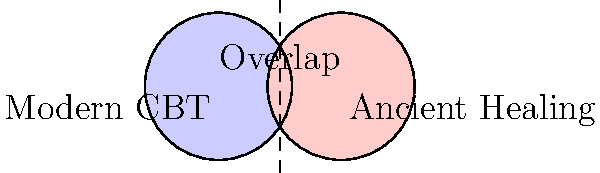In the Venn diagram above, which area represents techniques that are unique to modern Cognitive Behavioral Therapy (CBT) and not found in ancient healing practices? To answer this question, let's analyze the Venn diagram step by step:

1. The diagram consists of two overlapping circles.
2. The left circle (blue) represents "Modern CBT" techniques.
3. The right circle (red) represents "Ancient Healing" practices.
4. The overlapping area in the middle represents techniques that are common to both modern CBT and ancient healing practices.

5. To find the area that represents techniques unique to modern CBT, we need to identify the portion of the "Modern CBT" circle that does not overlap with the "Ancient Healing" circle.

6. This unique area is the left part of the blue circle, which does not intersect with the red circle.

7. In set theory notation, this area can be expressed as:
   $$ \text{Modern CBT} \setminus \text{Ancient Healing} $$
   which reads as "Modern CBT minus Ancient Healing" or "the set of elements in Modern CBT that are not in Ancient Healing."

Therefore, the area representing techniques unique to modern CBT is the left portion of the blue circle, excluding the overlapping region.
Answer: The left (blue) non-overlapping portion of the "Modern CBT" circle 